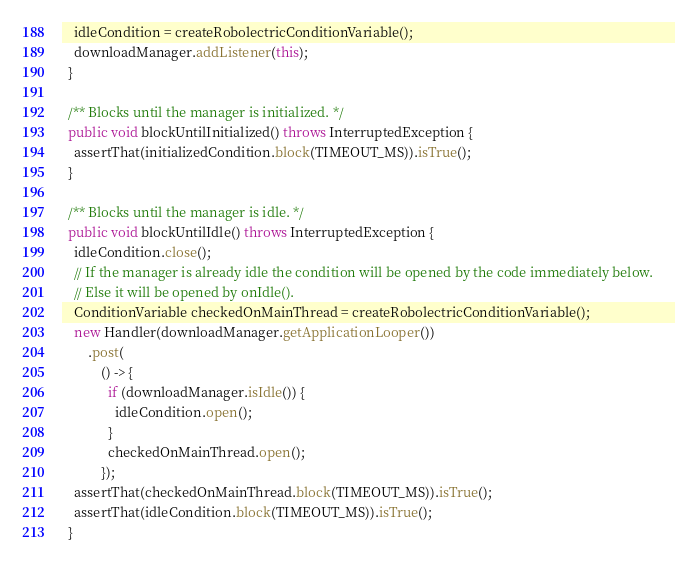Convert code to text. <code><loc_0><loc_0><loc_500><loc_500><_Java_>    idleCondition = createRobolectricConditionVariable();
    downloadManager.addListener(this);
  }

  /** Blocks until the manager is initialized. */
  public void blockUntilInitialized() throws InterruptedException {
    assertThat(initializedCondition.block(TIMEOUT_MS)).isTrue();
  }

  /** Blocks until the manager is idle. */
  public void blockUntilIdle() throws InterruptedException {
    idleCondition.close();
    // If the manager is already idle the condition will be opened by the code immediately below.
    // Else it will be opened by onIdle().
    ConditionVariable checkedOnMainThread = createRobolectricConditionVariable();
    new Handler(downloadManager.getApplicationLooper())
        .post(
            () -> {
              if (downloadManager.isIdle()) {
                idleCondition.open();
              }
              checkedOnMainThread.open();
            });
    assertThat(checkedOnMainThread.block(TIMEOUT_MS)).isTrue();
    assertThat(idleCondition.block(TIMEOUT_MS)).isTrue();
  }
</code> 